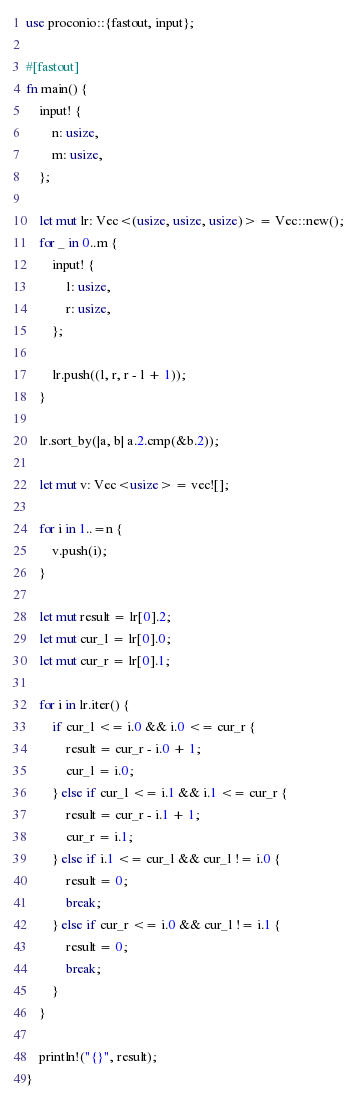<code> <loc_0><loc_0><loc_500><loc_500><_Rust_>use proconio::{fastout, input};

#[fastout]
fn main() {
    input! {
        n: usize,
        m: usize,
    };

    let mut lr: Vec<(usize, usize, usize)> = Vec::new();
    for _ in 0..m {
        input! {
            l: usize,
            r: usize,
        };

        lr.push((l, r, r - l + 1));
    }

    lr.sort_by(|a, b| a.2.cmp(&b.2));

    let mut v: Vec<usize> = vec![];

    for i in 1..=n {
        v.push(i);
    }

    let mut result = lr[0].2;
    let mut cur_l = lr[0].0;
    let mut cur_r = lr[0].1;

    for i in lr.iter() {
        if cur_l <= i.0 && i.0 <= cur_r {
            result = cur_r - i.0 + 1;
            cur_l = i.0;
        } else if cur_l <= i.1 && i.1 <= cur_r {
            result = cur_r - i.1 + 1;
            cur_r = i.1;
        } else if i.1 <= cur_l && cur_l != i.0 {
            result = 0;
            break;
        } else if cur_r <= i.0 && cur_l != i.1 {
            result = 0;
            break;
        }
    }

    println!("{}", result);
}
</code> 